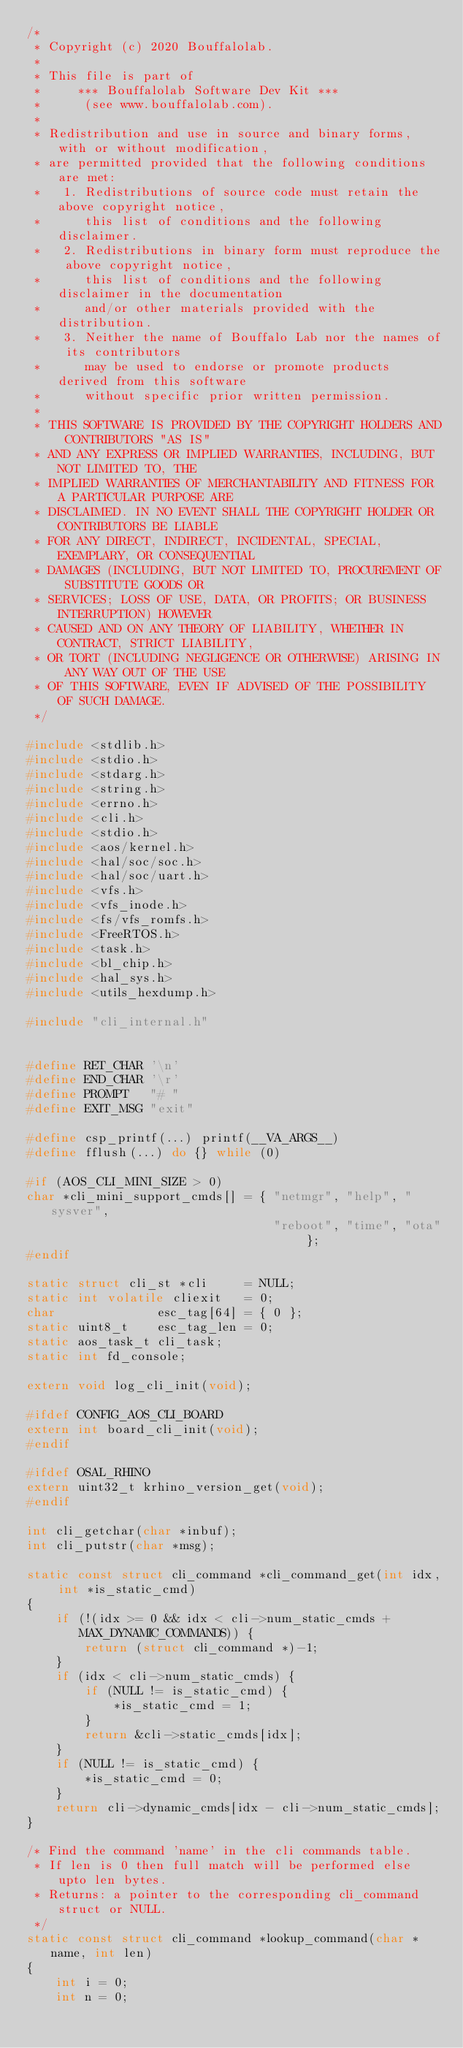Convert code to text. <code><loc_0><loc_0><loc_500><loc_500><_C_>/*
 * Copyright (c) 2020 Bouffalolab.
 *
 * This file is part of
 *     *** Bouffalolab Software Dev Kit ***
 *      (see www.bouffalolab.com).
 *
 * Redistribution and use in source and binary forms, with or without modification,
 * are permitted provided that the following conditions are met:
 *   1. Redistributions of source code must retain the above copyright notice,
 *      this list of conditions and the following disclaimer.
 *   2. Redistributions in binary form must reproduce the above copyright notice,
 *      this list of conditions and the following disclaimer in the documentation
 *      and/or other materials provided with the distribution.
 *   3. Neither the name of Bouffalo Lab nor the names of its contributors
 *      may be used to endorse or promote products derived from this software
 *      without specific prior written permission.
 *
 * THIS SOFTWARE IS PROVIDED BY THE COPYRIGHT HOLDERS AND CONTRIBUTORS "AS IS"
 * AND ANY EXPRESS OR IMPLIED WARRANTIES, INCLUDING, BUT NOT LIMITED TO, THE
 * IMPLIED WARRANTIES OF MERCHANTABILITY AND FITNESS FOR A PARTICULAR PURPOSE ARE
 * DISCLAIMED. IN NO EVENT SHALL THE COPYRIGHT HOLDER OR CONTRIBUTORS BE LIABLE
 * FOR ANY DIRECT, INDIRECT, INCIDENTAL, SPECIAL, EXEMPLARY, OR CONSEQUENTIAL
 * DAMAGES (INCLUDING, BUT NOT LIMITED TO, PROCUREMENT OF SUBSTITUTE GOODS OR
 * SERVICES; LOSS OF USE, DATA, OR PROFITS; OR BUSINESS INTERRUPTION) HOWEVER
 * CAUSED AND ON ANY THEORY OF LIABILITY, WHETHER IN CONTRACT, STRICT LIABILITY,
 * OR TORT (INCLUDING NEGLIGENCE OR OTHERWISE) ARISING IN ANY WAY OUT OF THE USE
 * OF THIS SOFTWARE, EVEN IF ADVISED OF THE POSSIBILITY OF SUCH DAMAGE.
 */

#include <stdlib.h>
#include <stdio.h>
#include <stdarg.h>
#include <string.h>
#include <errno.h>
#include <cli.h>
#include <stdio.h>
#include <aos/kernel.h>
#include <hal/soc/soc.h>
#include <hal/soc/uart.h>
#include <vfs.h>
#include <vfs_inode.h>
#include <fs/vfs_romfs.h>
#include <FreeRTOS.h>
#include <task.h>
#include <bl_chip.h>
#include <hal_sys.h>
#include <utils_hexdump.h>

#include "cli_internal.h"


#define RET_CHAR '\n'
#define END_CHAR '\r'
#define PROMPT   "# "
#define EXIT_MSG "exit"

#define csp_printf(...) printf(__VA_ARGS__)
#define fflush(...) do {} while (0)

#if (AOS_CLI_MINI_SIZE > 0)
char *cli_mini_support_cmds[] = { "netmgr", "help", "sysver",
                                  "reboot", "time", "ota" };
#endif

static struct cli_st *cli     = NULL;
static int volatile cliexit   = 0;
char              esc_tag[64] = { 0 };
static uint8_t    esc_tag_len = 0;
static aos_task_t cli_task;
static int fd_console;

extern void log_cli_init(void);

#ifdef CONFIG_AOS_CLI_BOARD
extern int board_cli_init(void);
#endif

#ifdef OSAL_RHINO
extern uint32_t krhino_version_get(void);
#endif

int cli_getchar(char *inbuf);
int cli_putstr(char *msg);

static const struct cli_command *cli_command_get(int idx, int *is_static_cmd)
{
    if (!(idx >= 0 && idx < cli->num_static_cmds + MAX_DYNAMIC_COMMANDS)) {
        return (struct cli_command *)-1;
    }
    if (idx < cli->num_static_cmds) {
        if (NULL != is_static_cmd) {
            *is_static_cmd = 1;
        }
        return &cli->static_cmds[idx];
    }
    if (NULL != is_static_cmd) {
        *is_static_cmd = 0;
    }
    return cli->dynamic_cmds[idx - cli->num_static_cmds];
}

/* Find the command 'name' in the cli commands table.
 * If len is 0 then full match will be performed else upto len bytes.
 * Returns: a pointer to the corresponding cli_command struct or NULL.
 */
static const struct cli_command *lookup_command(char *name, int len)
{
    int i = 0;
    int n = 0;
</code> 